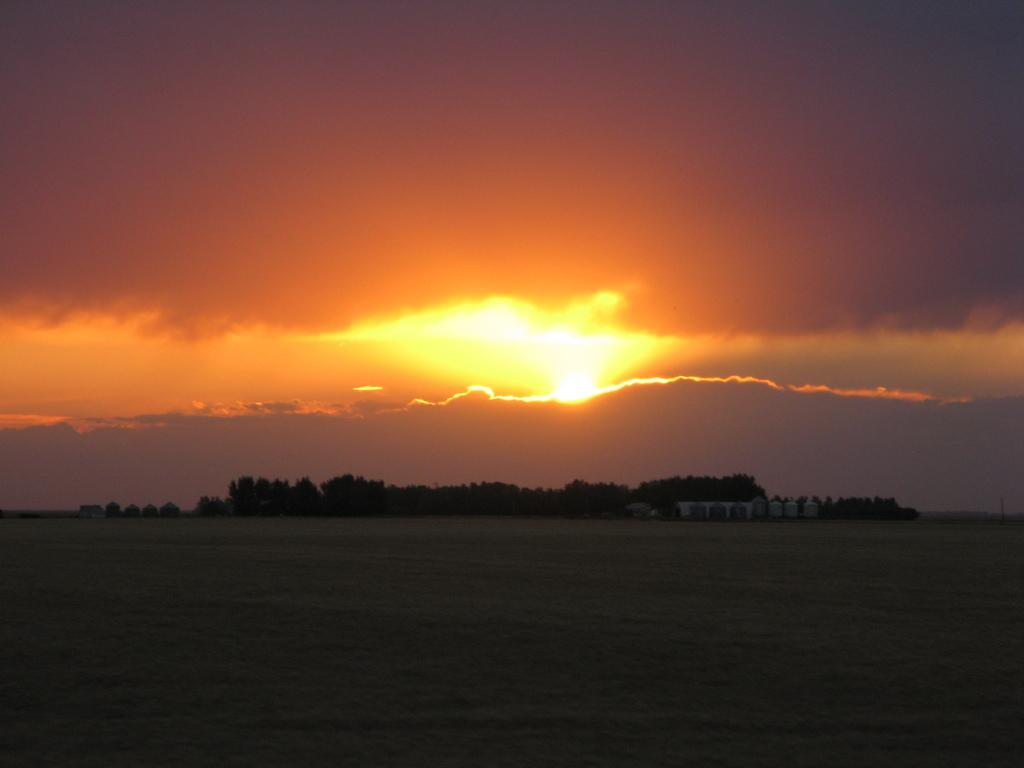What type of vegetation can be seen in the image? There are trees in the image. What celestial body is visible in the image? The sun is visible in the image. What atmospheric phenomena can be seen in the image? Clouds are present in the image. What part of the natural environment is visible in the image? The sky is visible in the image. What is the color of the sky in the image? The color of the sky is orange. How many babies are present in the image? There are no babies present in the image. What invention is being demonstrated in the image? There is no invention being demonstrated in the image. 